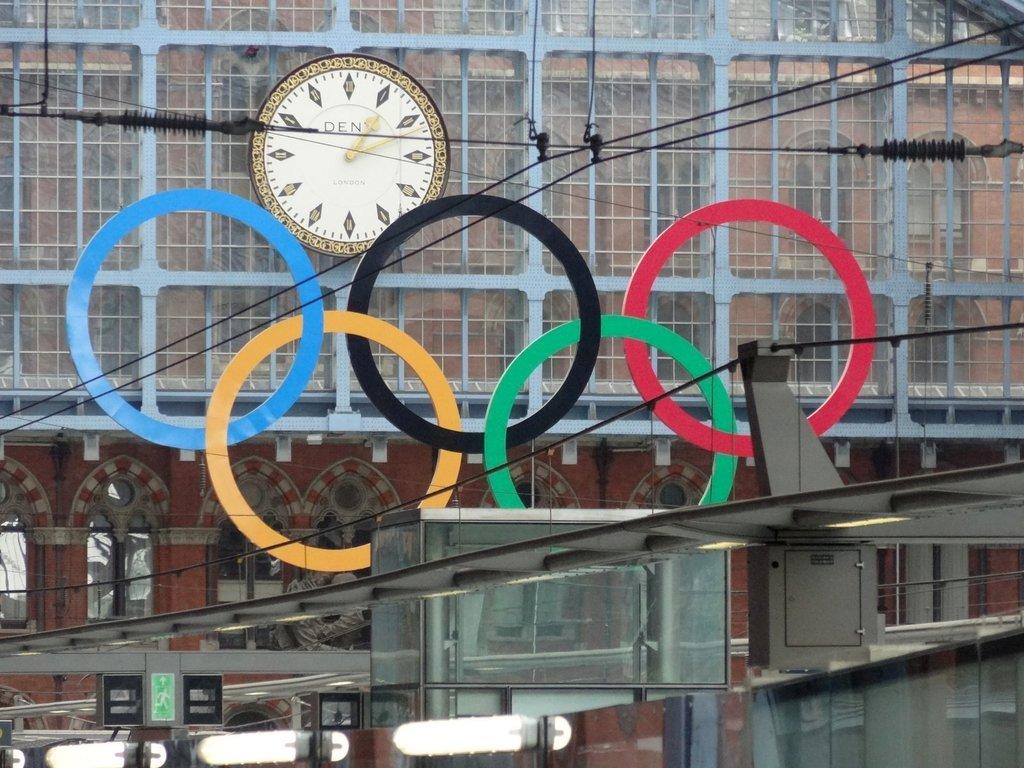What time is it?
Your answer should be very brief. 1:11. 